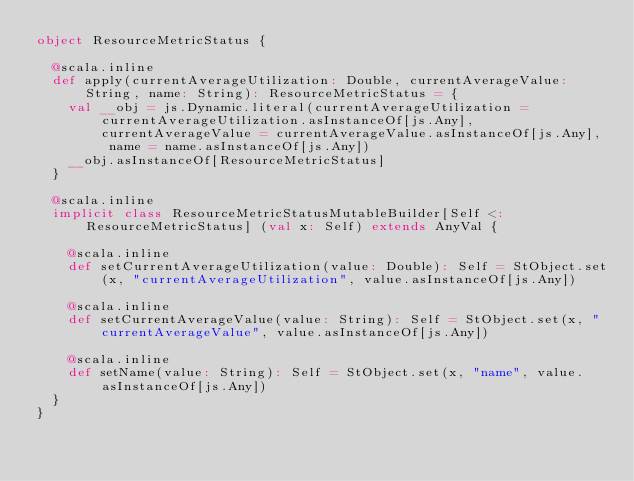Convert code to text. <code><loc_0><loc_0><loc_500><loc_500><_Scala_>object ResourceMetricStatus {
  
  @scala.inline
  def apply(currentAverageUtilization: Double, currentAverageValue: String, name: String): ResourceMetricStatus = {
    val __obj = js.Dynamic.literal(currentAverageUtilization = currentAverageUtilization.asInstanceOf[js.Any], currentAverageValue = currentAverageValue.asInstanceOf[js.Any], name = name.asInstanceOf[js.Any])
    __obj.asInstanceOf[ResourceMetricStatus]
  }
  
  @scala.inline
  implicit class ResourceMetricStatusMutableBuilder[Self <: ResourceMetricStatus] (val x: Self) extends AnyVal {
    
    @scala.inline
    def setCurrentAverageUtilization(value: Double): Self = StObject.set(x, "currentAverageUtilization", value.asInstanceOf[js.Any])
    
    @scala.inline
    def setCurrentAverageValue(value: String): Self = StObject.set(x, "currentAverageValue", value.asInstanceOf[js.Any])
    
    @scala.inline
    def setName(value: String): Self = StObject.set(x, "name", value.asInstanceOf[js.Any])
  }
}
</code> 